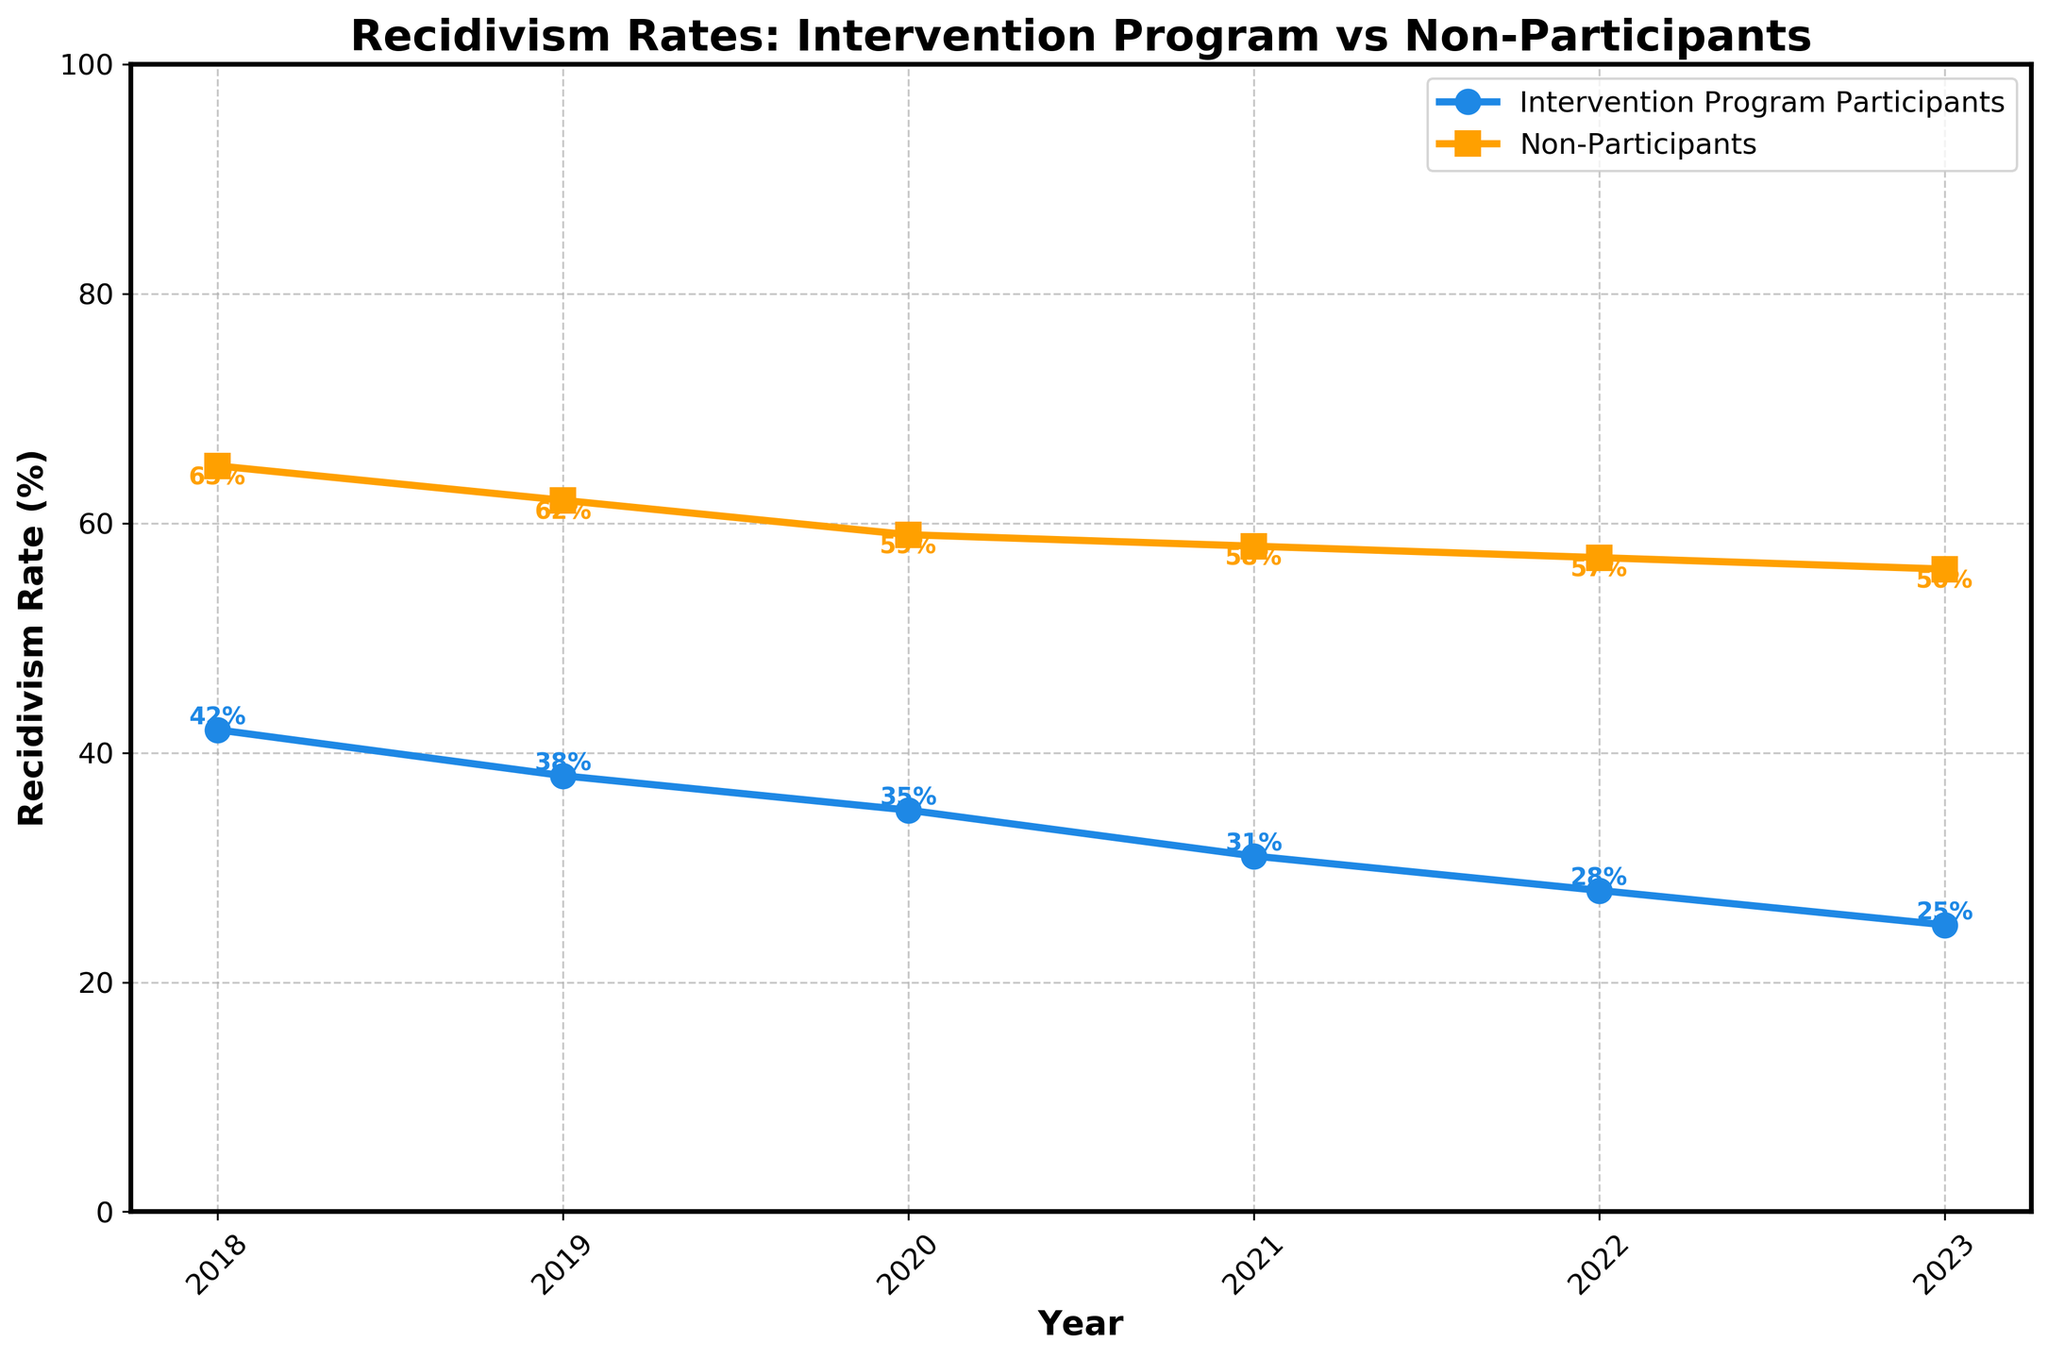What is the trend in recidivism rates for intervention program participants from 2018 to 2023? To identify the trend, we observe the recidivism rates for each year starting from 2018, where it is 42%, and decreasing each subsequent year to 25% in 2023.
Answer: Decreasing How do the recidivism rates of intervention program participants in 2018 compare to those in 2023? The recidivism rate for intervention program participants in 2018 is 42%, while in 2023 it is 25%. Subtracting 25 from 42, we see a decrease of 17%.
Answer: 17% What year saw the smallest difference in recidivism rates between intervention program participants and non-participants? For each year, find the difference between the two groups. The differences are: 2018: 23%, 2019: 24%, 2020: 24%, 2021: 27%, 2022: 29%, 2023: 31%. The smallest difference is 23% in 2018.
Answer: 2018 Which group had a consistently lower recidivism rate? Observing the plot across all years from 2018 to 2023, the intervention program participants consistently have lower recidivism rates compared to non-participants.
Answer: Intervention program participants How does the recidivism rate for non-participants in 2023 compare to their rate in 2018? In 2023, the recidivism rate for non-participants is 56%, and in 2018 it is 65%. The rate decreased by 9%.
Answer: 9% By how much did the recidivism rate for intervention program participants decrease from 2019 to 2020? The recidivism rate for intervention program participants in 2019 is 38% and in 2020 it is 35%. The decrease is 38% - 35% = 3%.
Answer: 3% What year had the highest recidivism rate for non-participants and what was the rate? By inspecting the recidivism rates for non-participants over the years, 2018 has the highest rate of 65%.
Answer: 2018, 65% Between which consecutive years did the recidivism rate for intervention program participants decrease the most? Calculate the yearly differences: 2018-2019: 42% - 38% = 4%, 2019-2020: 38% - 35% = 3%, 2020-2021: 35% - 31% = 4%, 2021-2022: 31% - 28% = 3%, 2022-2023: 28% - 25% = 3%. The highest decrease is from 2018 to 2019 and from 2020 to 2021 with 4%.
Answer: 2018-2019 and 2020-2021 What's the average recidivism rate for non-participants from 2018 to 2023? Sum the rates for non-participants: 65% + 62% + 59% + 58% + 57% + 56% = 357%, then divide by the number of years, 357% / 6 ≈ 59.5%.
Answer: 59.5% What were the recidivism rates for intervention program participants and non-participants in 2021? By looking at the plot, the recidivism rates in 2021 are 31% for intervention program participants and 58% for non-participants.
Answer: 31%, 58% 